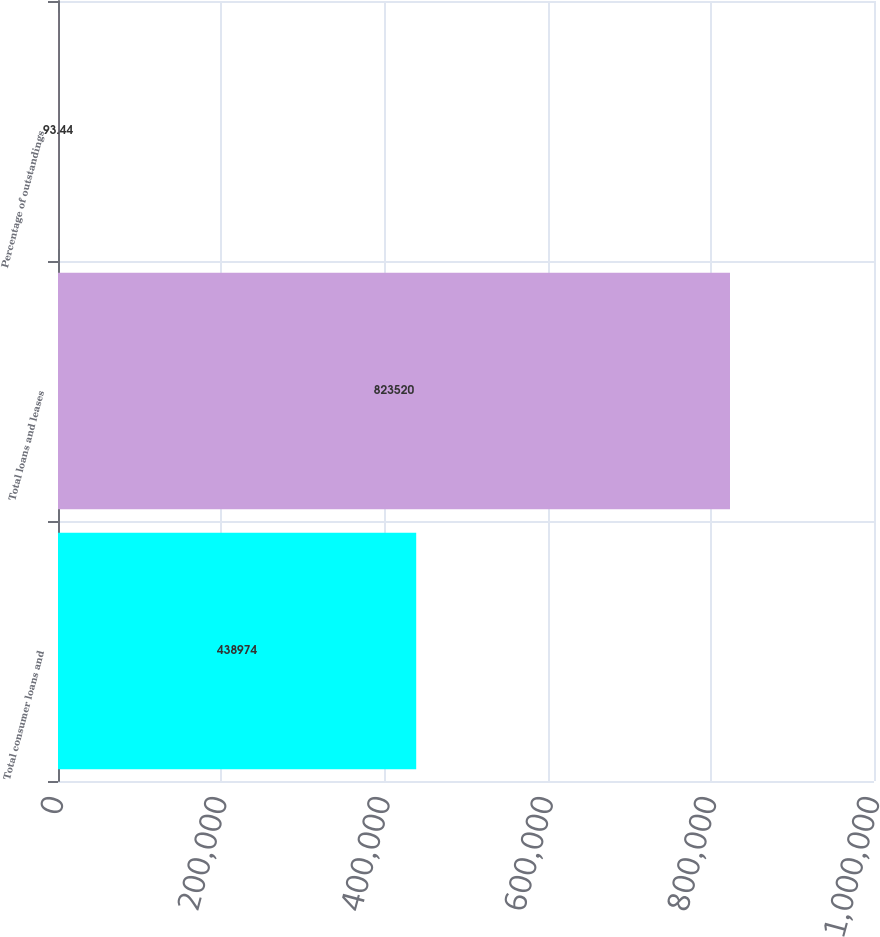Convert chart. <chart><loc_0><loc_0><loc_500><loc_500><bar_chart><fcel>Total consumer loans and<fcel>Total loans and leases<fcel>Percentage of outstandings<nl><fcel>438974<fcel>823520<fcel>93.44<nl></chart> 